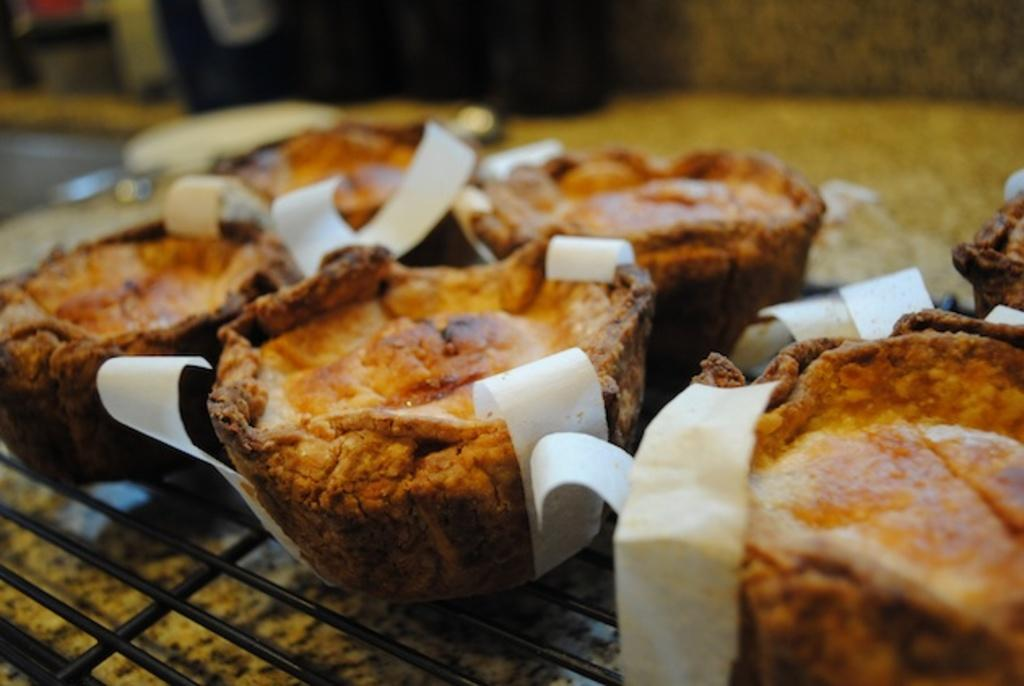What type of food can be seen in the image? The food in the image has orange and brown colors. How is the food being prepared? The food is on a grill. What color is the substance on top of the food? The food has white color things on it. Can you describe the background of the image? The background of the image is blurred. How many family members are present in the image? There is no family present in the image; it only features food on a grill. What type of underwear is visible in the image? There is no underwear present in the image. 